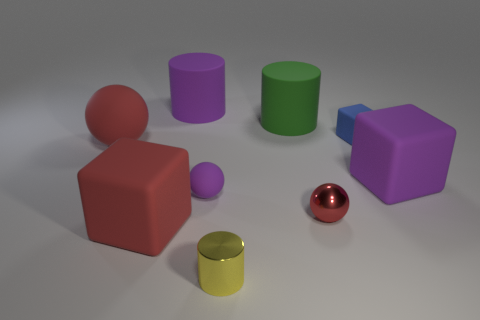Add 1 large balls. How many objects exist? 10 Subtract all gray cylinders. Subtract all purple spheres. How many cylinders are left? 3 Subtract all balls. How many objects are left? 6 Add 4 small shiny balls. How many small shiny balls are left? 5 Add 2 large green things. How many large green things exist? 3 Subtract 0 cyan balls. How many objects are left? 9 Subtract all large blue rubber cylinders. Subtract all big red things. How many objects are left? 7 